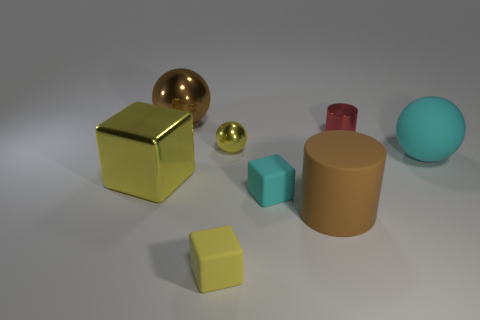What color is the small metallic thing that is the same shape as the large brown matte object?
Ensure brevity in your answer.  Red. Is there any other thing that has the same color as the big rubber sphere?
Offer a terse response. Yes. How many other things are there of the same material as the big brown ball?
Your response must be concise. 3. How big is the red cylinder?
Offer a very short reply. Small. Are there any red things that have the same shape as the tiny cyan object?
Provide a short and direct response. No. How many things are big green shiny cylinders or large metal things that are in front of the cyan ball?
Provide a short and direct response. 1. The block that is on the right side of the small yellow rubber object is what color?
Make the answer very short. Cyan. Is the size of the cyan matte object to the left of the red metal object the same as the sphere in front of the small metallic ball?
Provide a succinct answer. No. Are there any other balls of the same size as the matte sphere?
Offer a terse response. Yes. How many brown metal balls are to the left of the big brown metal sphere behind the large yellow block?
Offer a very short reply. 0. 